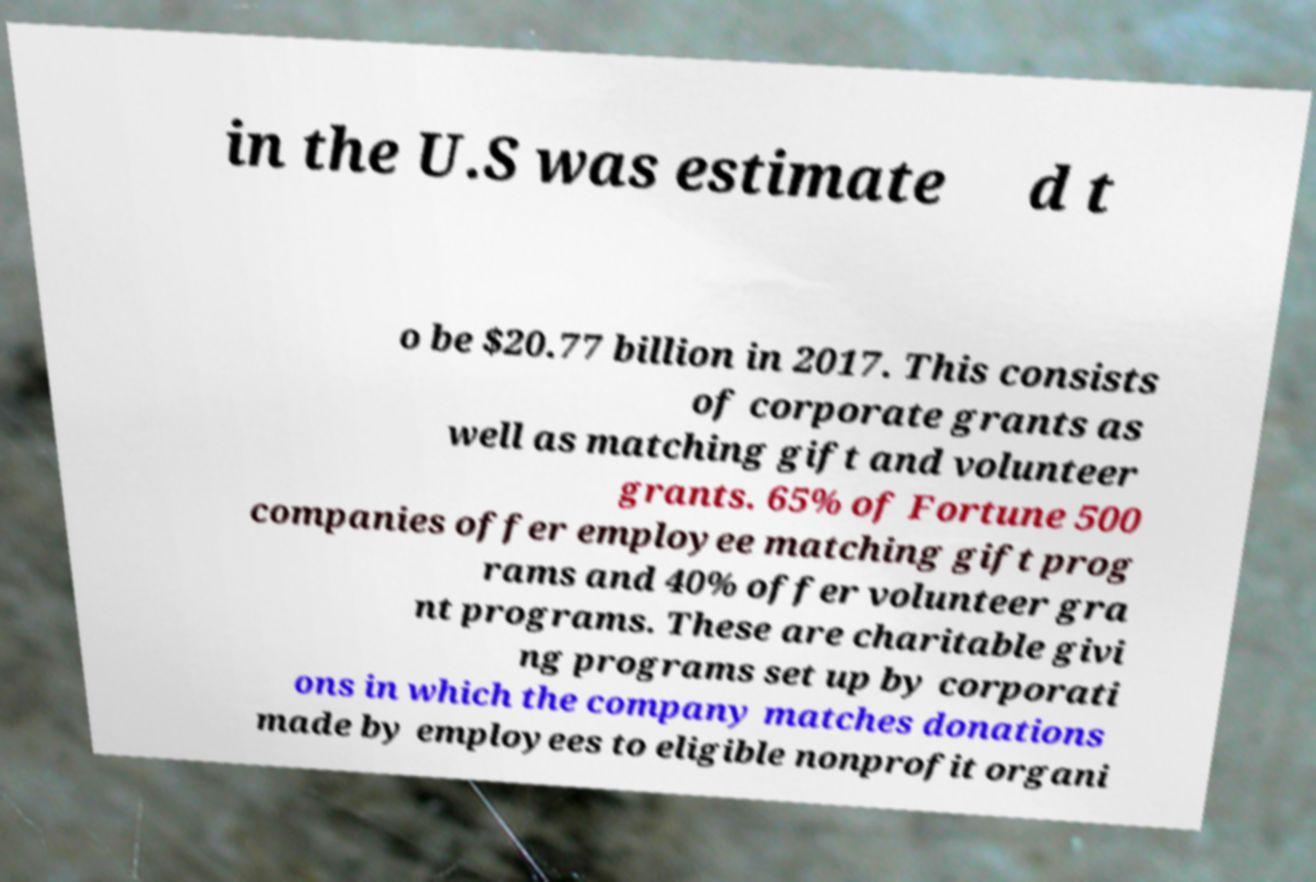Could you extract and type out the text from this image? in the U.S was estimate d t o be $20.77 billion in 2017. This consists of corporate grants as well as matching gift and volunteer grants. 65% of Fortune 500 companies offer employee matching gift prog rams and 40% offer volunteer gra nt programs. These are charitable givi ng programs set up by corporati ons in which the company matches donations made by employees to eligible nonprofit organi 